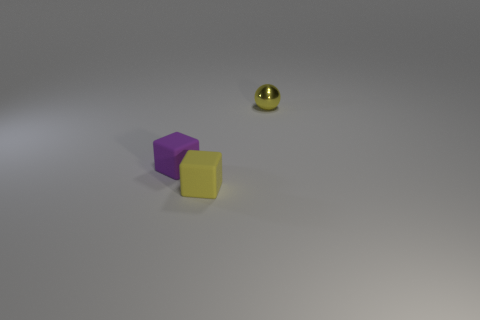Add 3 small purple spheres. How many objects exist? 6 Subtract all balls. How many objects are left? 2 Subtract 0 yellow cylinders. How many objects are left? 3 Subtract all balls. Subtract all large brown metal objects. How many objects are left? 2 Add 1 tiny purple matte blocks. How many tiny purple matte blocks are left? 2 Add 3 tiny yellow shiny balls. How many tiny yellow shiny balls exist? 4 